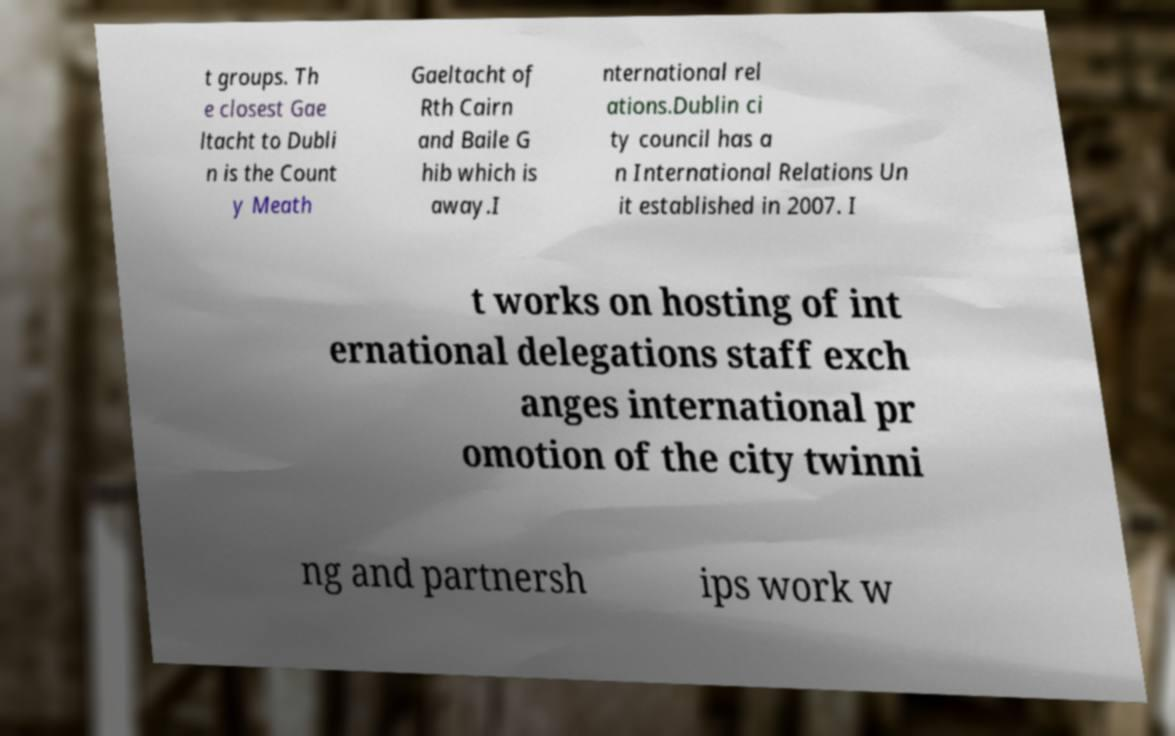There's text embedded in this image that I need extracted. Can you transcribe it verbatim? t groups. Th e closest Gae ltacht to Dubli n is the Count y Meath Gaeltacht of Rth Cairn and Baile G hib which is away.I nternational rel ations.Dublin ci ty council has a n International Relations Un it established in 2007. I t works on hosting of int ernational delegations staff exch anges international pr omotion of the city twinni ng and partnersh ips work w 